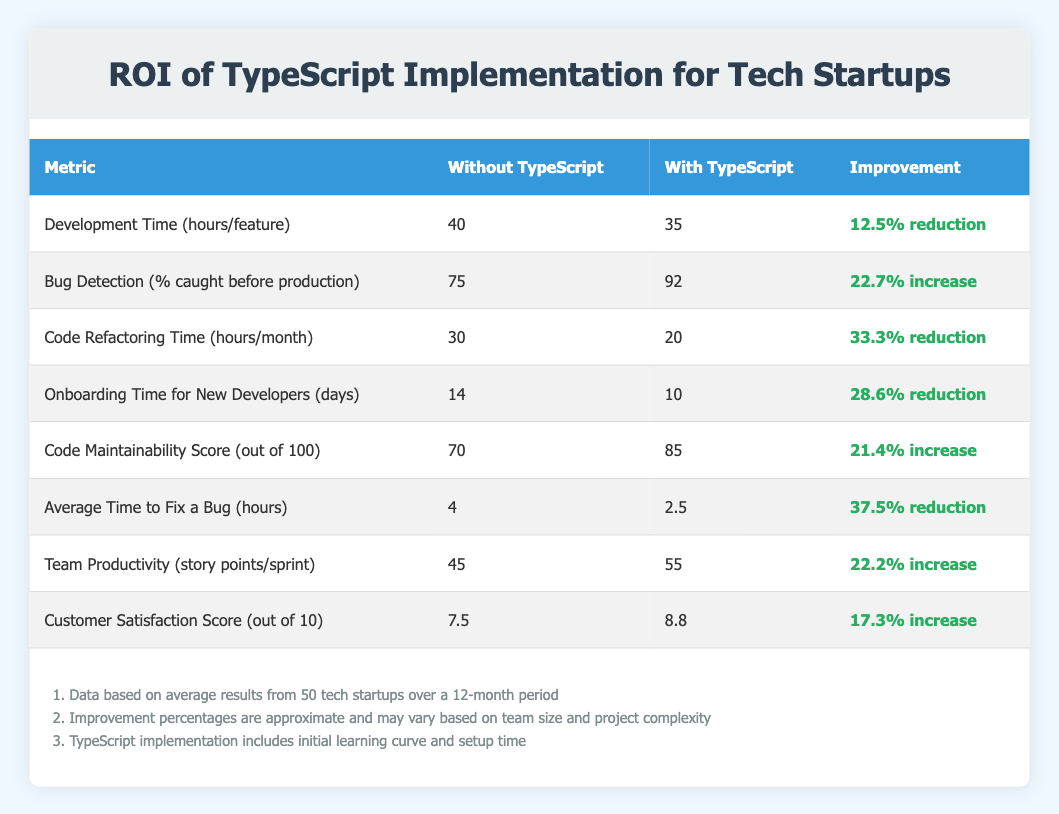What is the development time per feature without TypeScript? The table directly states that the development time per feature without TypeScript is 40 hours.
Answer: 40 hours What percentage increase in bug detection does using TypeScript provide? The table shows that the percentage of bug detection caught before production increases from 75% to 92% when using TypeScript. The improvement is calculated as (92 - 75) / 75 * 100% = 22.7%.
Answer: 22.7% What is the total reduction in hours for code refactoring time when implementing TypeScript? Without TypeScript, the code refactoring time is 30 hours per month, and with TypeScript, it is 20 hours. The total reduction is calculated as 30 - 20 = 10 hours.
Answer: 10 hours Is the customer satisfaction score higher with TypeScript than without it? The table provides a customer satisfaction score of 8.8 with TypeScript and 7.5 without it, indicating that the score is higher when TypeScript is implemented.
Answer: Yes What is the average difference in team productivity between using TypeScript and not? The team productivity without TypeScript is 45 story points per sprint, compared to 55 with TypeScript. The difference in productivity is 55 - 45 = 10 story points.
Answer: 10 story points How much has the average time to fix a bug been reduced by implementing TypeScript? The average time to fix a bug without TypeScript is 4 hours, and with TypeScript, it is 2.5 hours. The reduction in time is calculated as 4 - 2.5 = 1.5 hours.
Answer: 1.5 hours What is the average improvement across all metrics from the table? To find the average improvement, we first translate each improvement into a numerical value: -12.5% for development time, 22.7% for bug detection, -33.3% for refactoring time, -28.6% for onboarding time, 21.4% for maintainability, -37.5% for bug fix time, 22.2% for productivity, and 17.3% for customer satisfaction. Summing the numerical values gives (-12.5 + 22.7 - 33.3 - 28.6 + 21.4 - 37.5 + 22.2 + 17.3) = - 25.7. Dividing by 8 metrics gives an average improvement of -3.21%.
Answer: -3.21% Is the average time to fix a bug longer without TypeScript compared to with it? According to the table, the average time without TypeScript is 4 hours, while with TypeScript, it is 2.5 hours. Therefore, it is indeed longer without TypeScript.
Answer: Yes What is the difference in the code maintainability score when using TypeScript? The score for code maintainability without TypeScript is 70, and with TypeScript, it is 85. The difference is calculated as 85 - 70 = 15.
Answer: 15 